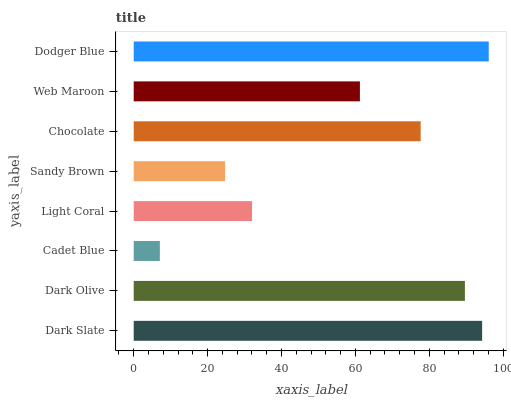Is Cadet Blue the minimum?
Answer yes or no. Yes. Is Dodger Blue the maximum?
Answer yes or no. Yes. Is Dark Olive the minimum?
Answer yes or no. No. Is Dark Olive the maximum?
Answer yes or no. No. Is Dark Slate greater than Dark Olive?
Answer yes or no. Yes. Is Dark Olive less than Dark Slate?
Answer yes or no. Yes. Is Dark Olive greater than Dark Slate?
Answer yes or no. No. Is Dark Slate less than Dark Olive?
Answer yes or no. No. Is Chocolate the high median?
Answer yes or no. Yes. Is Web Maroon the low median?
Answer yes or no. Yes. Is Light Coral the high median?
Answer yes or no. No. Is Cadet Blue the low median?
Answer yes or no. No. 